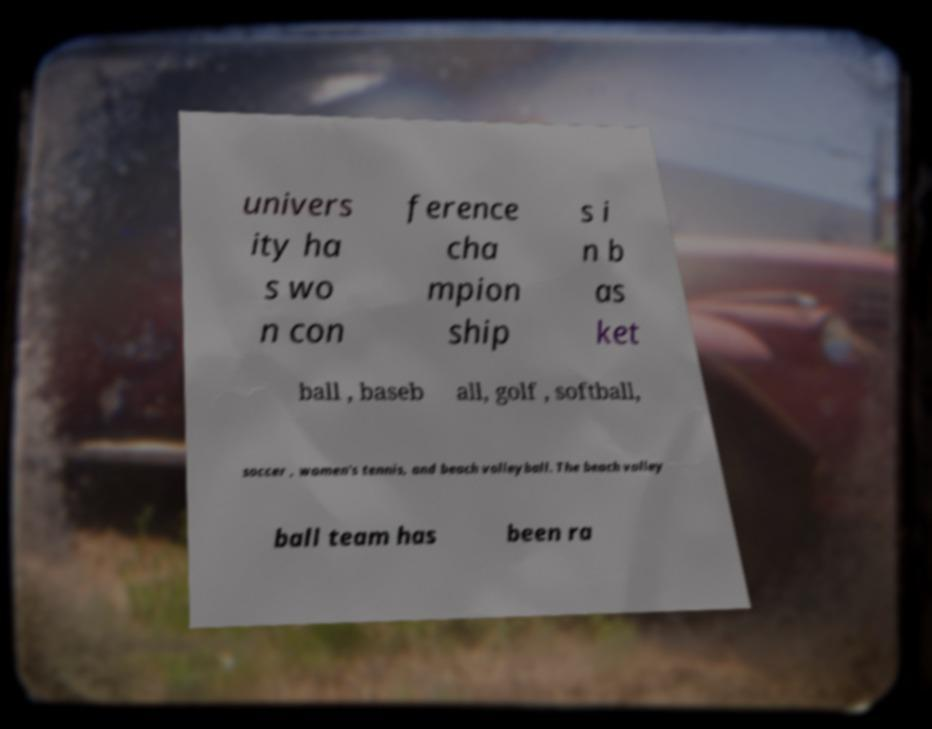For documentation purposes, I need the text within this image transcribed. Could you provide that? univers ity ha s wo n con ference cha mpion ship s i n b as ket ball , baseb all, golf , softball, soccer , women's tennis, and beach volleyball. The beach volley ball team has been ra 